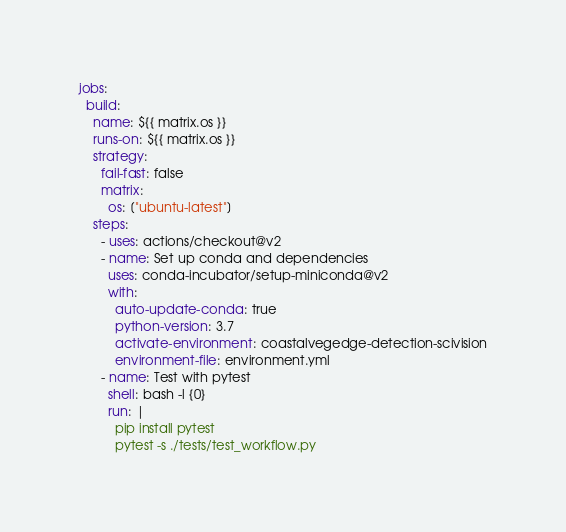<code> <loc_0><loc_0><loc_500><loc_500><_YAML_>jobs:
  build:
    name: ${{ matrix.os }}
    runs-on: ${{ matrix.os }}
    strategy:
      fail-fast: false
      matrix:
        os: ["ubuntu-latest"]
    steps:
      - uses: actions/checkout@v2
      - name: Set up conda and dependencies
        uses: conda-incubator/setup-miniconda@v2
        with:
          auto-update-conda: true
          python-version: 3.7
          activate-environment: coastalvegedge-detection-scivision
          environment-file: environment.yml
      - name: Test with pytest
        shell: bash -l {0}
        run: |
          pip install pytest
          pytest -s ./tests/test_workflow.py</code> 